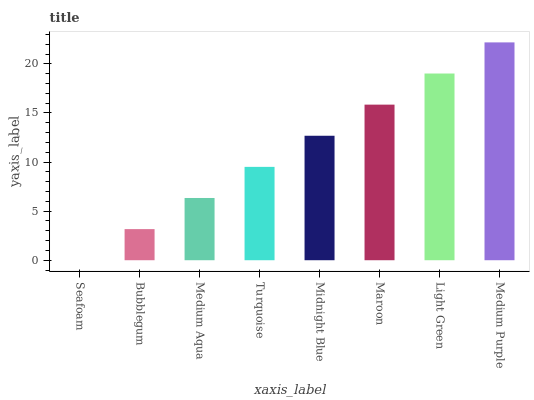Is Seafoam the minimum?
Answer yes or no. Yes. Is Medium Purple the maximum?
Answer yes or no. Yes. Is Bubblegum the minimum?
Answer yes or no. No. Is Bubblegum the maximum?
Answer yes or no. No. Is Bubblegum greater than Seafoam?
Answer yes or no. Yes. Is Seafoam less than Bubblegum?
Answer yes or no. Yes. Is Seafoam greater than Bubblegum?
Answer yes or no. No. Is Bubblegum less than Seafoam?
Answer yes or no. No. Is Midnight Blue the high median?
Answer yes or no. Yes. Is Turquoise the low median?
Answer yes or no. Yes. Is Turquoise the high median?
Answer yes or no. No. Is Seafoam the low median?
Answer yes or no. No. 